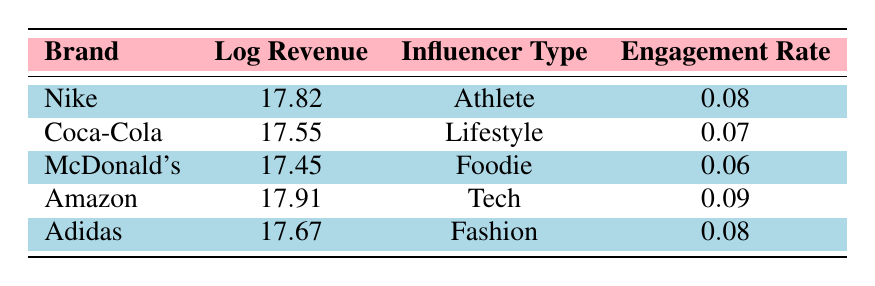What is the partnership revenue for Nike? According to the table, the partnership revenue for Nike is shown directly under the Partnership Revenue column. It states 55,000,000.
Answer: 55000000 Which brand has the highest partnership revenue? By comparing the values listed in the Partnership Revenue column, I can see that Amazon has the highest value at 60,000,000 compared to the others.
Answer: Amazon What is the engagement rate for Adidas? The engagement rate for Adidas is listed in the Engagement Rate column next to Adidas, which states 0.08.
Answer: 0.08 What is the difference in partnership revenue between Coca-Cola and McDonald's? The partnership revenue for Coca-Cola is 42,000,000 and for McDonald's is 38,000,000. To find the difference, I subtract 38,000,000 from 42,000,000. This equals 4,000,000.
Answer: 4000000 Is the engagement rate for Influencer Type "Foodie" higher than that for "Lifestyle"? The engagement rate for Foodie is 0.06 while for Lifestyle it is 0.07. Since 0.06 is less than 0.07, the statement is false.
Answer: No What is the average partnership revenue of the brands listed? The partnership revenues are 55,000,000 (Nike), 42,000,000 (Coca-Cola), 38,000,000 (McDonald's), 60,000,000 (Amazon), and 47,000,000 (Adidas). First, I add them: 55,000,000 + 42,000,000 + 38,000,000 + 60,000,000 + 47,000,000 = 242,000,000. Then I divide by 5 (the number of brands), resulting in an average of 48,400,000.
Answer: 48400000 Which influencer type has the highest engagement rate? I compare the engagement rates across all influencer types. Nike (Athlete) has 0.08, Coca-Cola (Lifestyle) has 0.07, McDonald's (Foodie) has 0.06, Amazon (Tech) has 0.09, and Adidas (Fashion) has 0.08. Amazon's engagement rate of 0.09 is the highest.
Answer: Amazon If you sum the partnership revenues of Athlete and Fashion influencer types, how much do you get? The partnership revenue for Athlete (Nike) is 55,000,000 and for Fashion (Adidas) is 47,000,000. Adding these values gives 55,000,000 + 47,000,000 = 102,000,000.
Answer: 102000000 